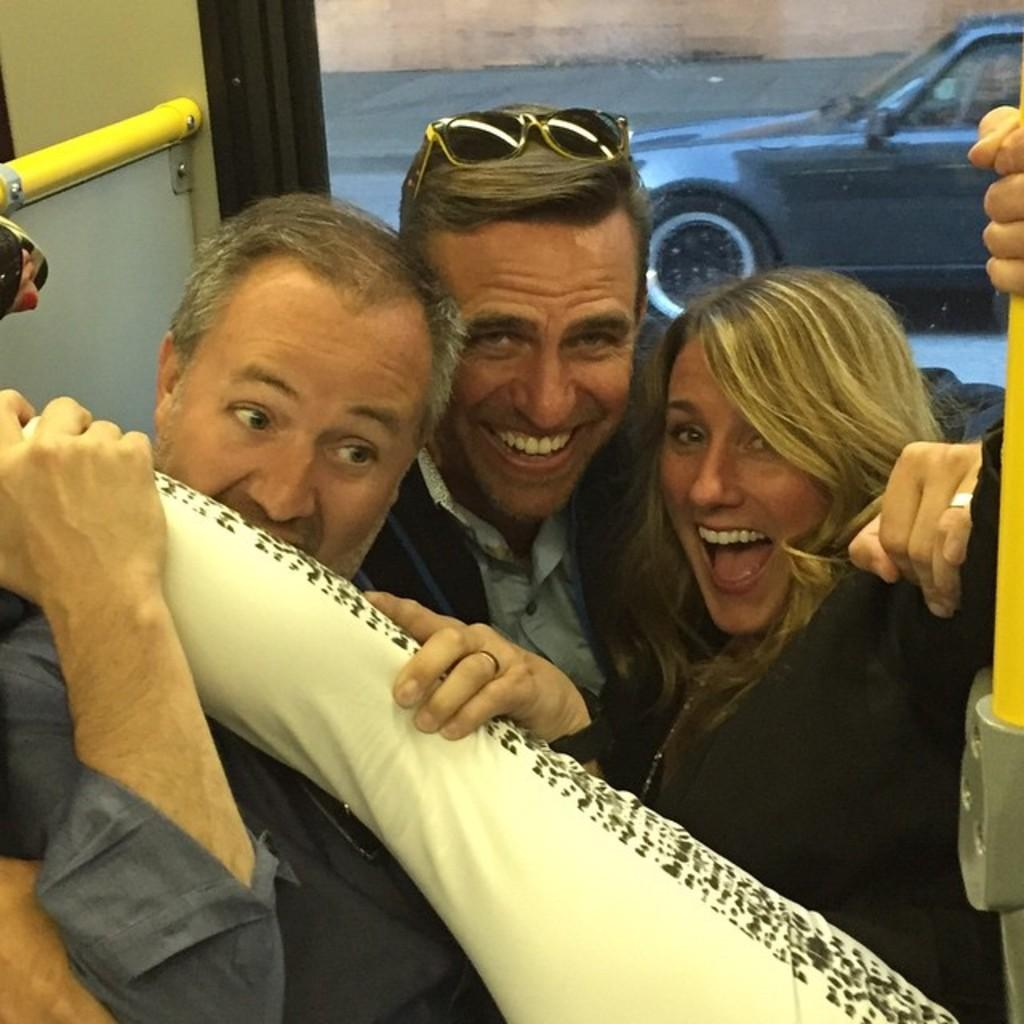What type of location is depicted in the image? The image is an inside view of a vehicle. How many people are present in the vehicle? There are three people in the vehicle. What is the man on the left side holding? The man is holding an object on the left side. What can be seen in the background of the image? There is a car, a path, and a wall visible in the background. What type of waves can be seen in the image? There are no waves present in the image; it is an inside view of a vehicle. 